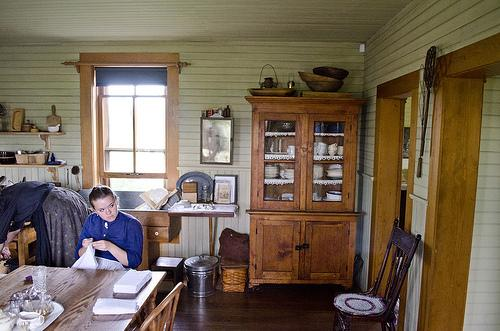In a casual tone, explain what can be found on the table. Oh, you'll see a glass, some cloth napkins, and a stack of white linens on the table. Count the number of windows present in the image. There is at least one window in the image. Mention any two pieces of furniture in the room and their features. There is a brown wood cabinet in the corner with dimensions width:121 and height:121, and a wood table in the dining room with dimensions width:163 and height:163. Using polite language, describe the chair provided in the dining room. There is a nice, fancy brown chair in the dining room with dimensions width:107 and height:107. It has a round cushion for added comfort. Tell me about the appearance of the woman sitting at the table. The woman is dressed in blue and has dark hair. She is sitting at a table with dimensions width:59 and height:59. What is the primary activity happening at the scene? A woman is sitting in the dining room, and there is a person bending over near her. In an informative tone, list any two objects on the floor. There is a metal bucket and a silver trash can on the floor, with dimensions width:33 and height:33 for the bucket and width:42 and height:42 for the trash can. What type of floor is in the image? Give details. The image features a dark brown hardwood floor with dimensions width:185 and height:185. 